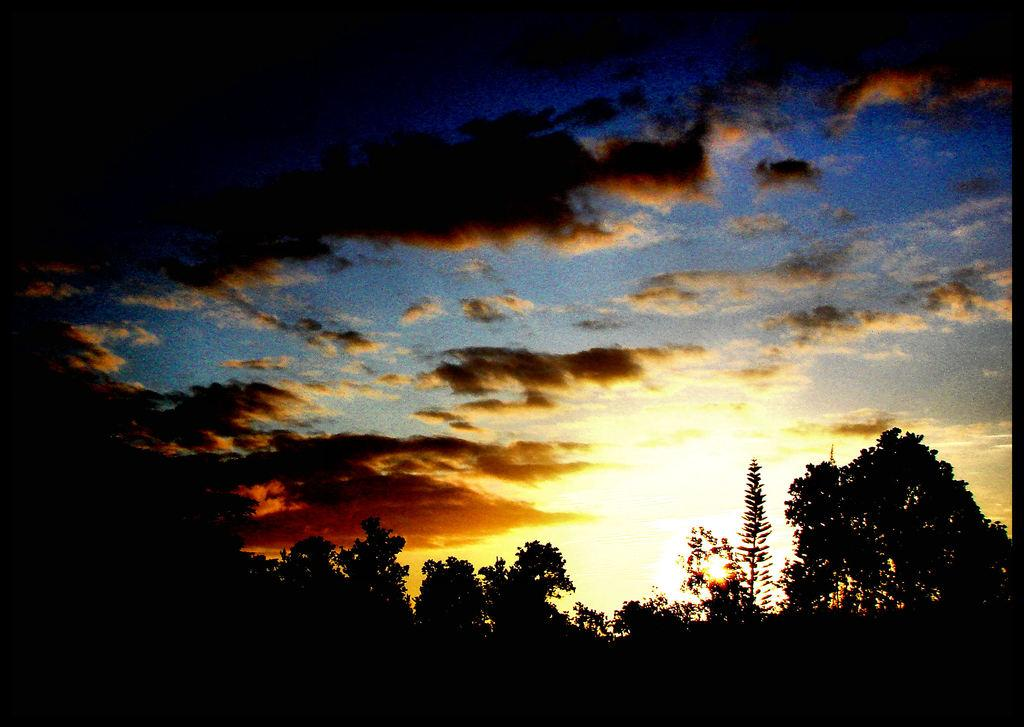What is the primary subject in the image? There are many trees in the image. What can be seen in the background of the image? There are clouds visible in the background of the image. What else is visible in the background of the image? The sky is visible in the background of the image. What type of pen is being used to draw the clouds in the image? There is no pen present in the image, and the clouds are not drawn; they are a natural part of the sky. What type of weather is depicted in the image? The image does not depict any specific weather conditions; it simply shows trees, clouds, and the sky. 